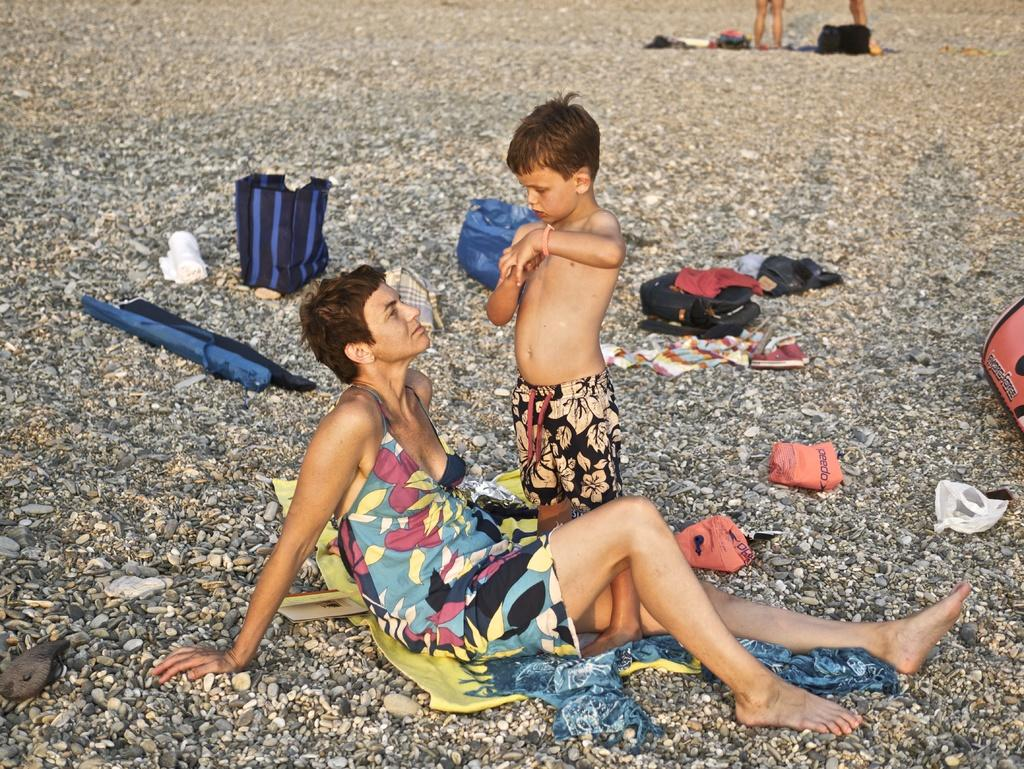Who are the people in the image? There is a lady and a small boy in the image. Where are the lady and the small boy located in the image? The lady and the small boy are in the center of the image. What is the floor made of in the image? The floor in the image is made of pebbles. How does the lady pull the cup from the small boy's hand in the image? There is no cup present in the image, and the lady is not interacting with the small boy in any way. 